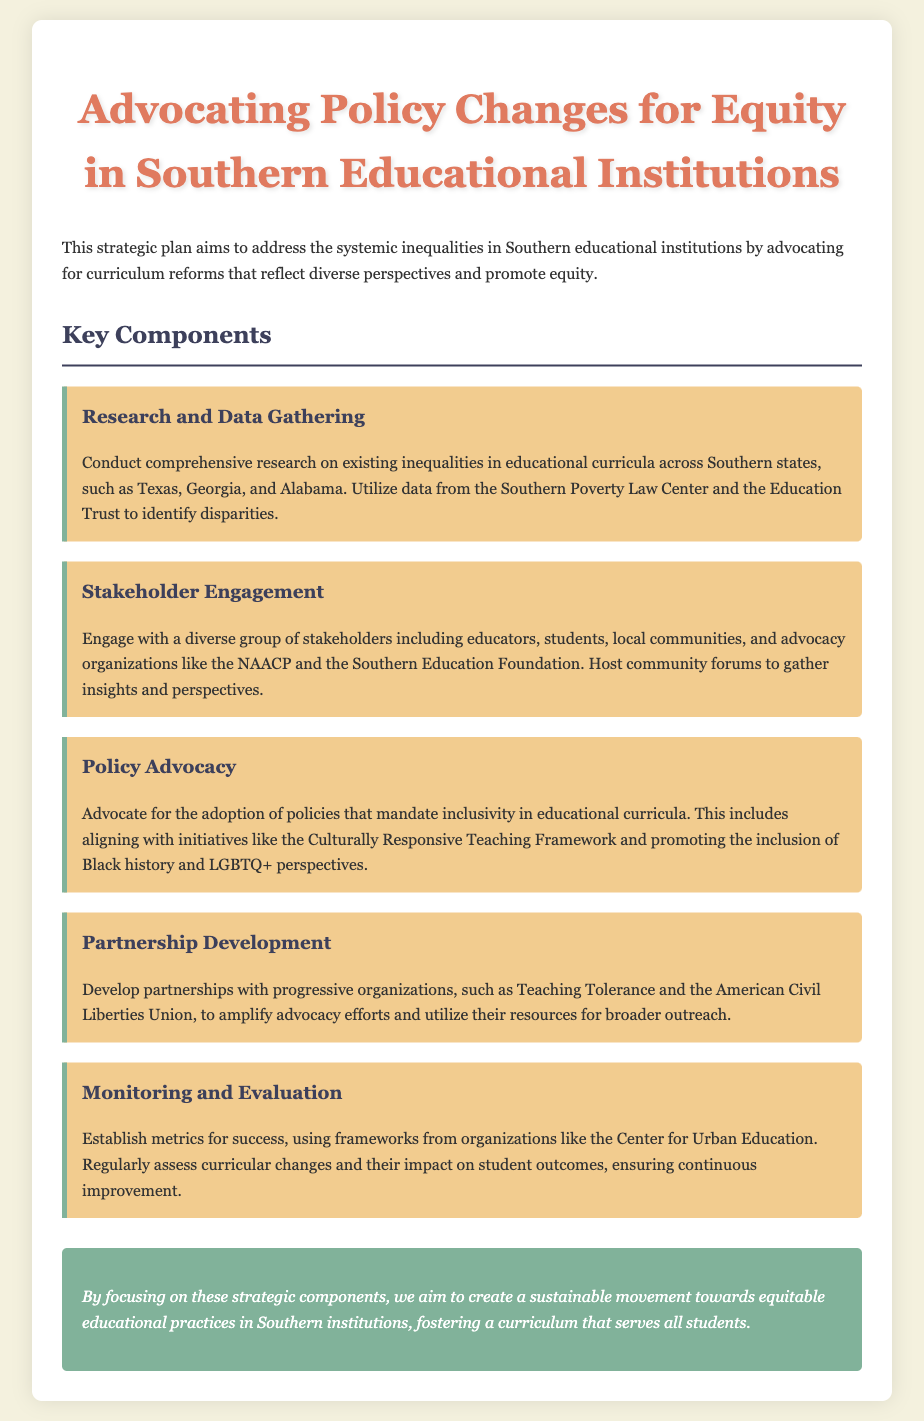What is the title of the document? The title is stated in the header of the document, which summarizes its main focus.
Answer: Advocating Policy Changes for Equity in Southern Educational Institutions What is one key component of the strategic plan? The key components are listed under the section "Key Components," highlighting critical areas for action.
Answer: Research and Data Gathering Which organizations are mentioned for partnership development? The document specifically lists organizations that can help amplify advocacy efforts under the "Partnership Development" section.
Answer: Teaching Tolerance and the American Civil Liberties Union What framework is suggested for curriculum inclusivity? This framework is mentioned in the "Policy Advocacy" section as part of the proposed policies for educational reform.
Answer: Culturally Responsive Teaching Framework What type of stakeholder engagement is recommended? The document discusses the importance of engaging various groups in a community setting for better insights and involvement.
Answer: Community forums What metrics are suggested for monitoring success? This information is provided in the "Monitoring and Evaluation" section, describing how to assess the impact of curricular changes.
Answer: Frameworks from organizations like the Center for Urban Education 